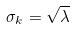<formula> <loc_0><loc_0><loc_500><loc_500>\sigma _ { k } = \sqrt { \lambda }</formula> 